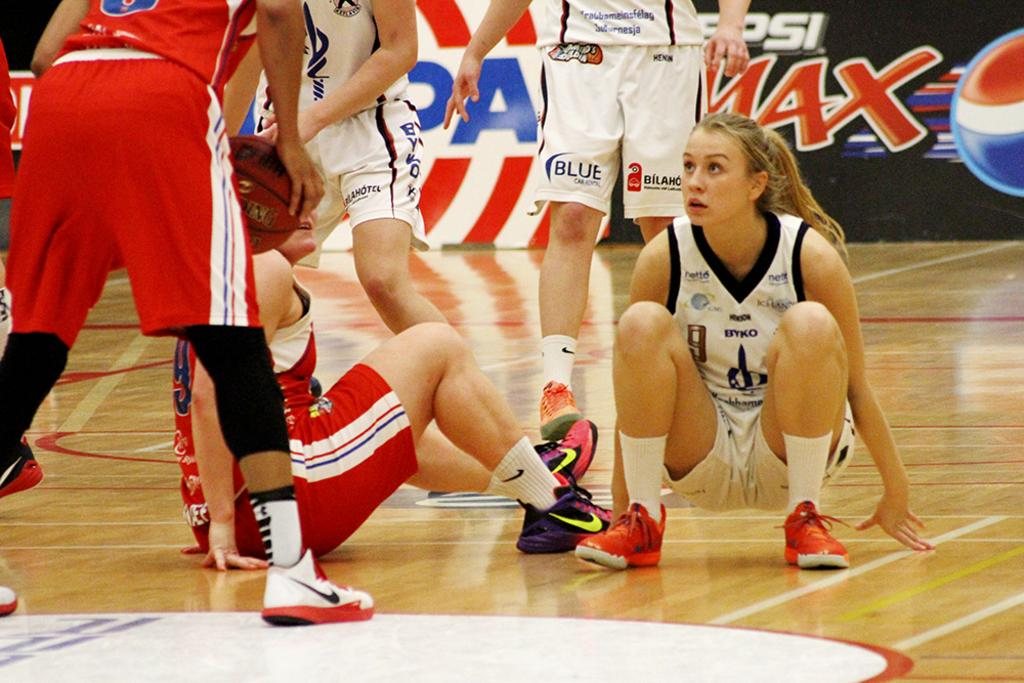<image>
Provide a brief description of the given image. A female basket ball player in red is on the floor with an opponent wearing white as their teamates play around them in front of a Pepsi Max advertising board.g 